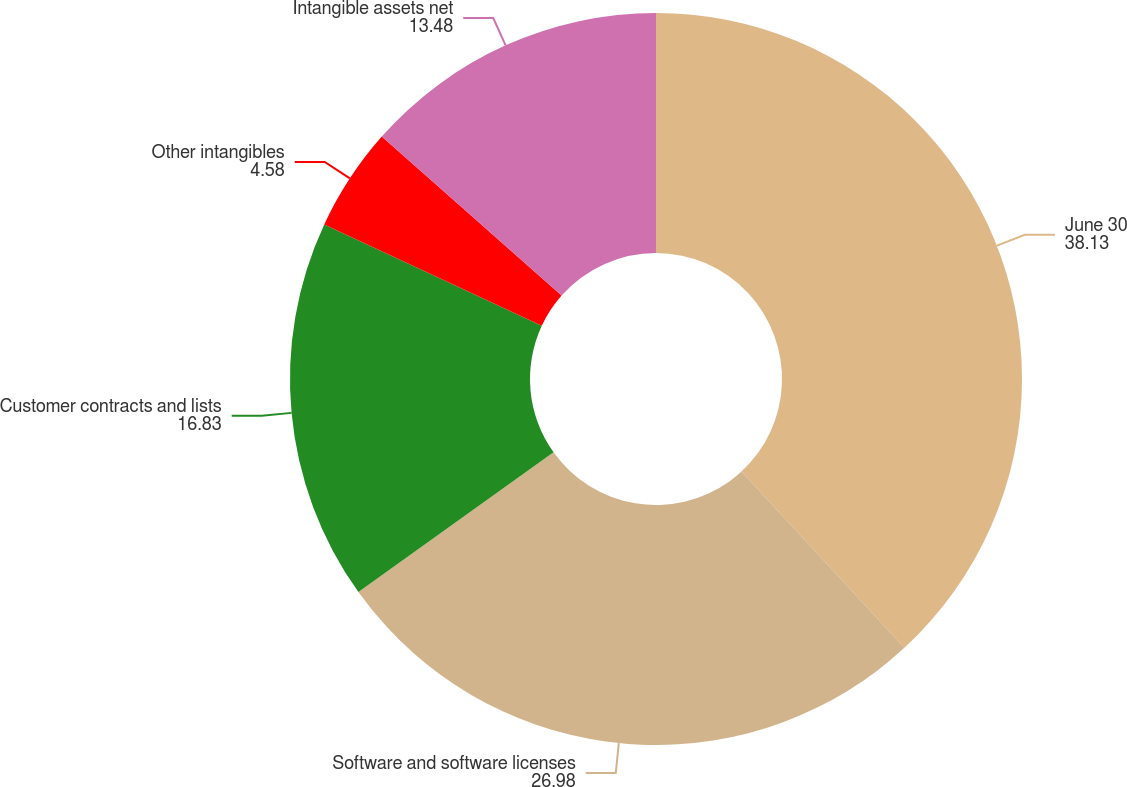Convert chart to OTSL. <chart><loc_0><loc_0><loc_500><loc_500><pie_chart><fcel>June 30<fcel>Software and software licenses<fcel>Customer contracts and lists<fcel>Other intangibles<fcel>Intangible assets net<nl><fcel>38.13%<fcel>26.98%<fcel>16.83%<fcel>4.58%<fcel>13.48%<nl></chart> 